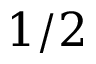<formula> <loc_0><loc_0><loc_500><loc_500>1 / 2</formula> 